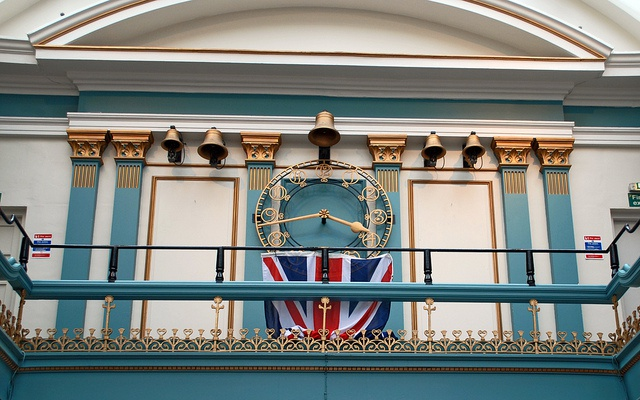Describe the objects in this image and their specific colors. I can see a clock in white and teal tones in this image. 